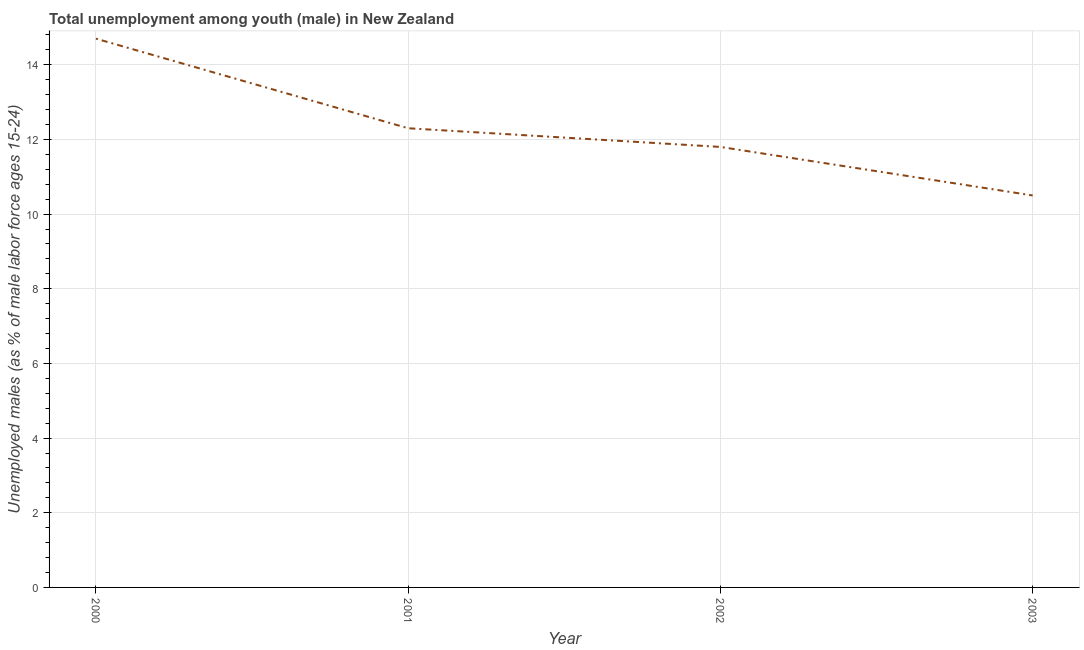What is the unemployed male youth population in 2000?
Give a very brief answer. 14.7. Across all years, what is the maximum unemployed male youth population?
Provide a succinct answer. 14.7. Across all years, what is the minimum unemployed male youth population?
Offer a terse response. 10.5. In which year was the unemployed male youth population minimum?
Your answer should be very brief. 2003. What is the sum of the unemployed male youth population?
Your response must be concise. 49.3. What is the difference between the unemployed male youth population in 2000 and 2002?
Give a very brief answer. 2.9. What is the average unemployed male youth population per year?
Provide a succinct answer. 12.33. What is the median unemployed male youth population?
Give a very brief answer. 12.05. In how many years, is the unemployed male youth population greater than 5.2 %?
Provide a succinct answer. 4. What is the ratio of the unemployed male youth population in 2000 to that in 2003?
Make the answer very short. 1.4. Is the unemployed male youth population in 2000 less than that in 2001?
Provide a succinct answer. No. Is the difference between the unemployed male youth population in 2002 and 2003 greater than the difference between any two years?
Provide a succinct answer. No. What is the difference between the highest and the second highest unemployed male youth population?
Your answer should be compact. 2.4. Is the sum of the unemployed male youth population in 2001 and 2003 greater than the maximum unemployed male youth population across all years?
Provide a short and direct response. Yes. What is the difference between the highest and the lowest unemployed male youth population?
Ensure brevity in your answer.  4.2. In how many years, is the unemployed male youth population greater than the average unemployed male youth population taken over all years?
Your response must be concise. 1. How many lines are there?
Provide a succinct answer. 1. Does the graph contain any zero values?
Your response must be concise. No. What is the title of the graph?
Your answer should be very brief. Total unemployment among youth (male) in New Zealand. What is the label or title of the X-axis?
Provide a short and direct response. Year. What is the label or title of the Y-axis?
Ensure brevity in your answer.  Unemployed males (as % of male labor force ages 15-24). What is the Unemployed males (as % of male labor force ages 15-24) of 2000?
Provide a succinct answer. 14.7. What is the Unemployed males (as % of male labor force ages 15-24) in 2001?
Your answer should be very brief. 12.3. What is the Unemployed males (as % of male labor force ages 15-24) in 2002?
Keep it short and to the point. 11.8. What is the difference between the Unemployed males (as % of male labor force ages 15-24) in 2001 and 2002?
Make the answer very short. 0.5. What is the ratio of the Unemployed males (as % of male labor force ages 15-24) in 2000 to that in 2001?
Your answer should be compact. 1.2. What is the ratio of the Unemployed males (as % of male labor force ages 15-24) in 2000 to that in 2002?
Provide a succinct answer. 1.25. What is the ratio of the Unemployed males (as % of male labor force ages 15-24) in 2001 to that in 2002?
Ensure brevity in your answer.  1.04. What is the ratio of the Unemployed males (as % of male labor force ages 15-24) in 2001 to that in 2003?
Ensure brevity in your answer.  1.17. What is the ratio of the Unemployed males (as % of male labor force ages 15-24) in 2002 to that in 2003?
Your answer should be compact. 1.12. 